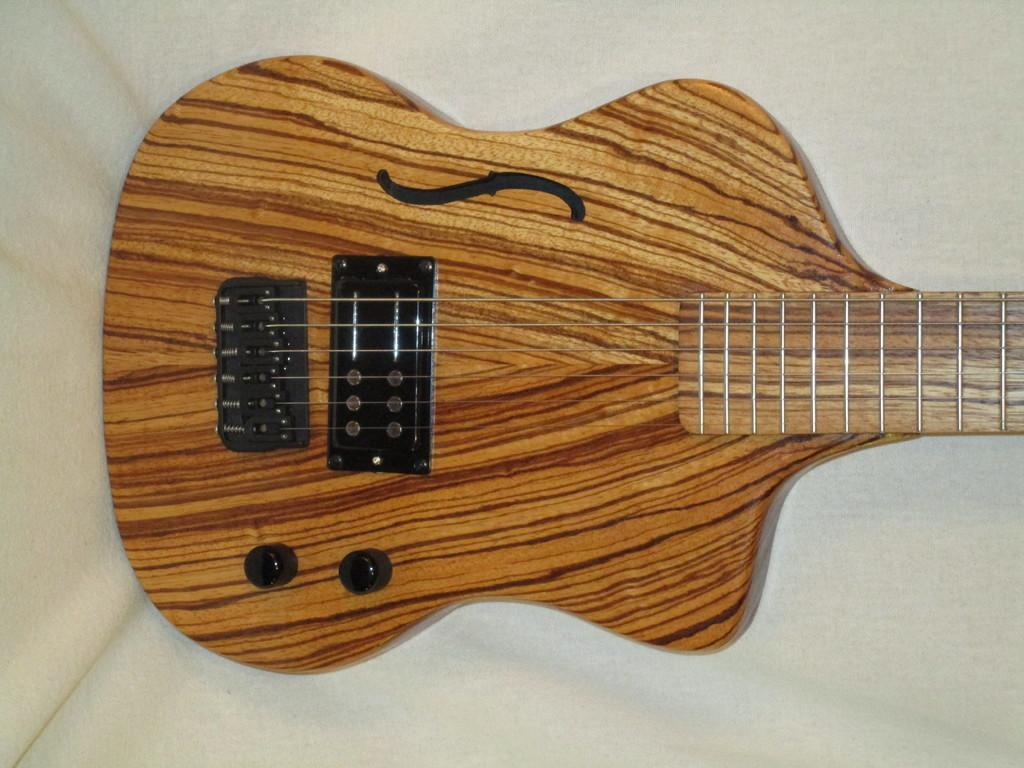What musical instrument is present in the image? There is a guitar in the image. What colors can be seen on the guitar? The guitar has a combination of brown and yellow colors. What color is present in the background of the image? The background of the image includes white color. Can you tell me how many girls are playing the guitar in the image? There is no girl present in the image, and the guitar is not being played. What type of thing is hanging around the guitar's neck in the image? There is no thing hanging around the guitar's neck in the image; the guitar is the only object visible. 